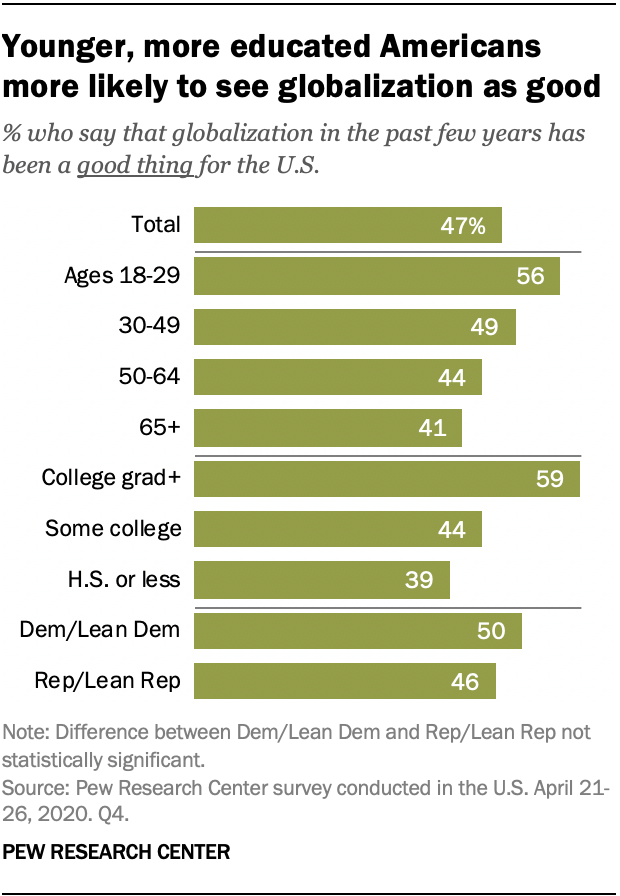Draw attention to some important aspects in this diagram. According to recent data, the percentage of college graduates in the United States is 59%. The data value for ages 30-49 is 49. 